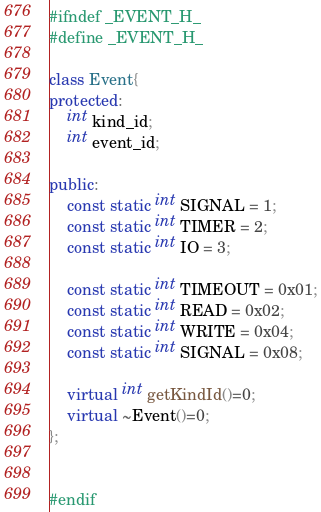<code> <loc_0><loc_0><loc_500><loc_500><_C++_>#ifndef _EVENT_H_
#define _EVENT_H_

class Event{
protected:
    int kind_id;
    int event_id;

public:
    const static int SIGNAL = 1;
    const static int TIMER = 2;
    const static int IO = 3;

    const static int TIMEOUT = 0x01;
    const static int READ = 0x02;
    const static int WRITE = 0x04;
    const static int SIGNAL = 0x08;

    virtual int getKindId()=0;
    virtual ~Event()=0;
};


#endif
</code> 